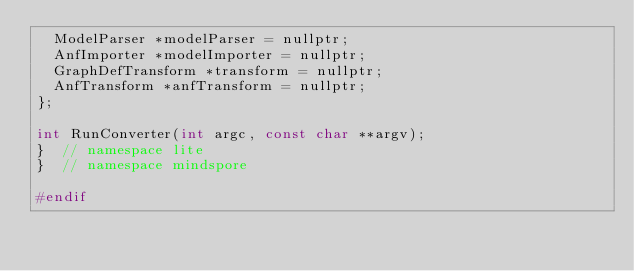Convert code to text. <code><loc_0><loc_0><loc_500><loc_500><_C_>  ModelParser *modelParser = nullptr;
  AnfImporter *modelImporter = nullptr;
  GraphDefTransform *transform = nullptr;
  AnfTransform *anfTransform = nullptr;
};

int RunConverter(int argc, const char **argv);
}  // namespace lite
}  // namespace mindspore

#endif
</code> 